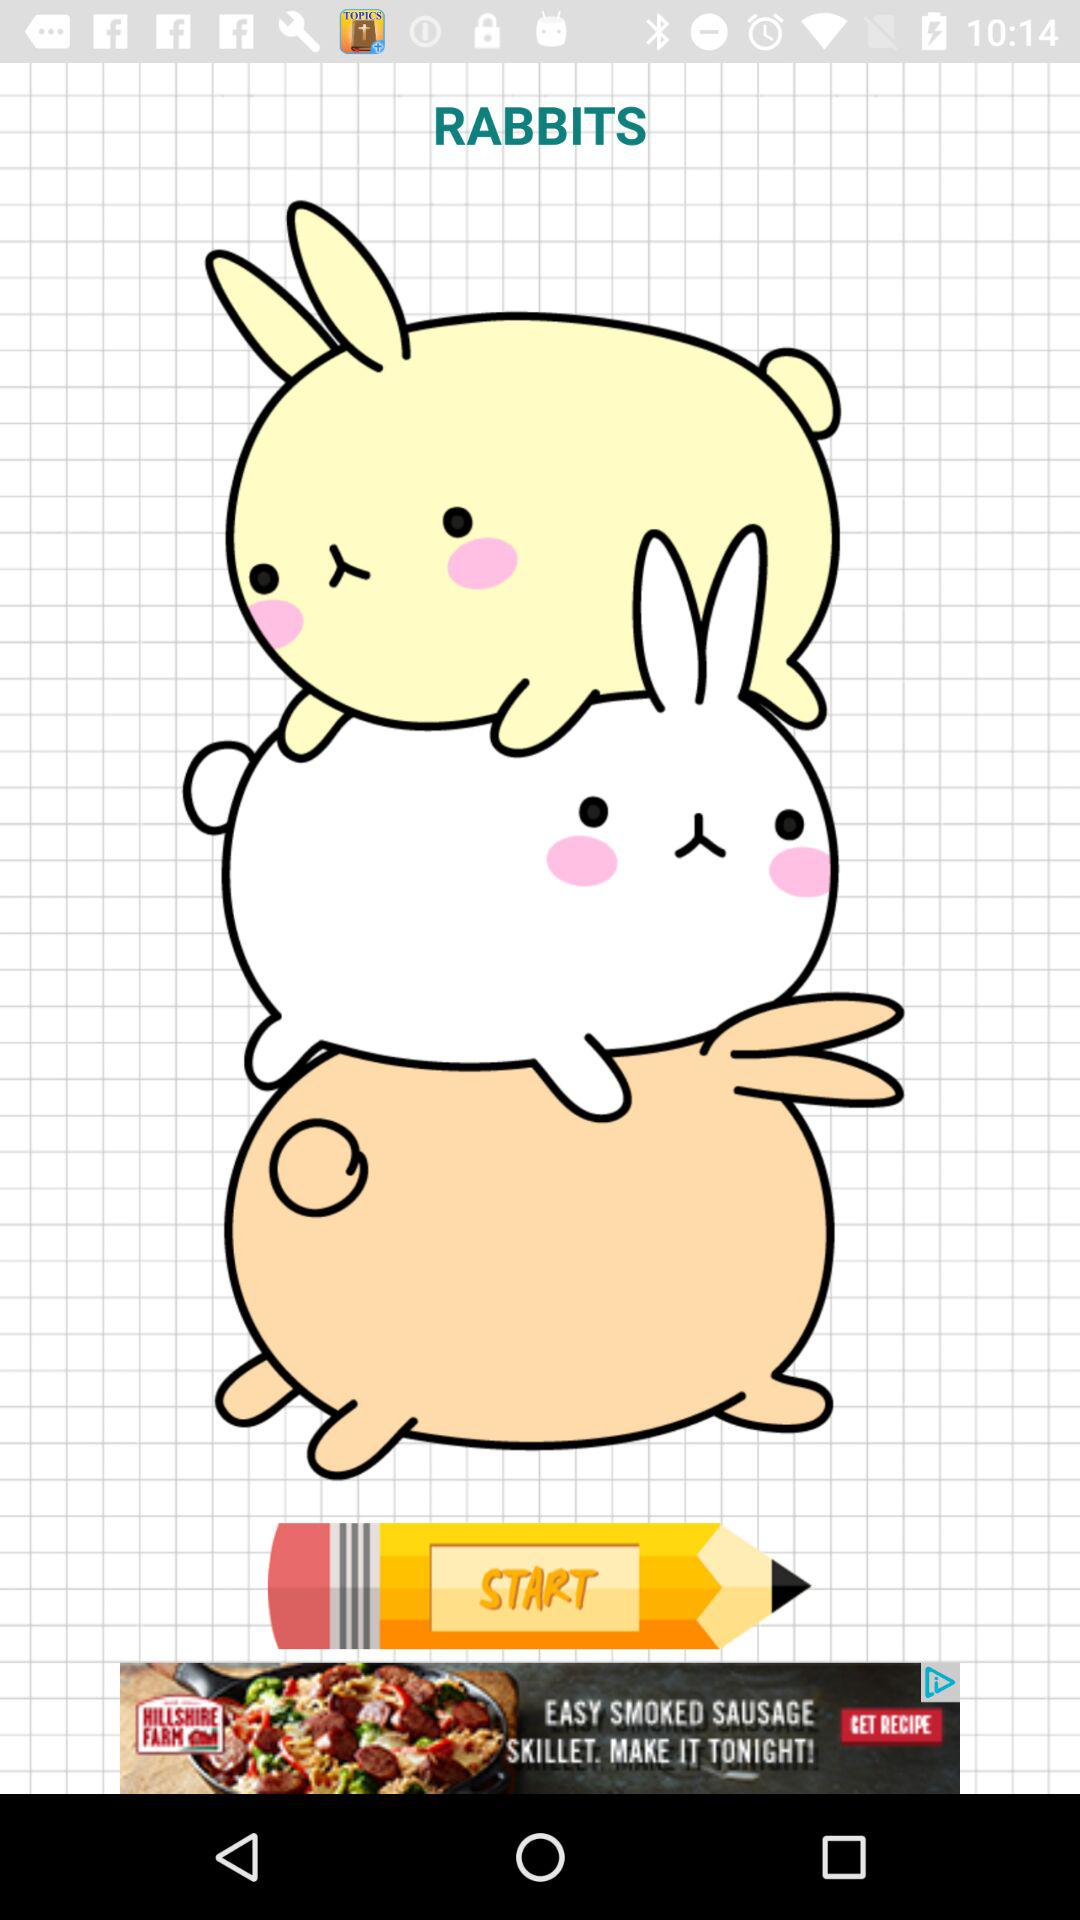What is the animal name? The animal name is "RABBITS". 